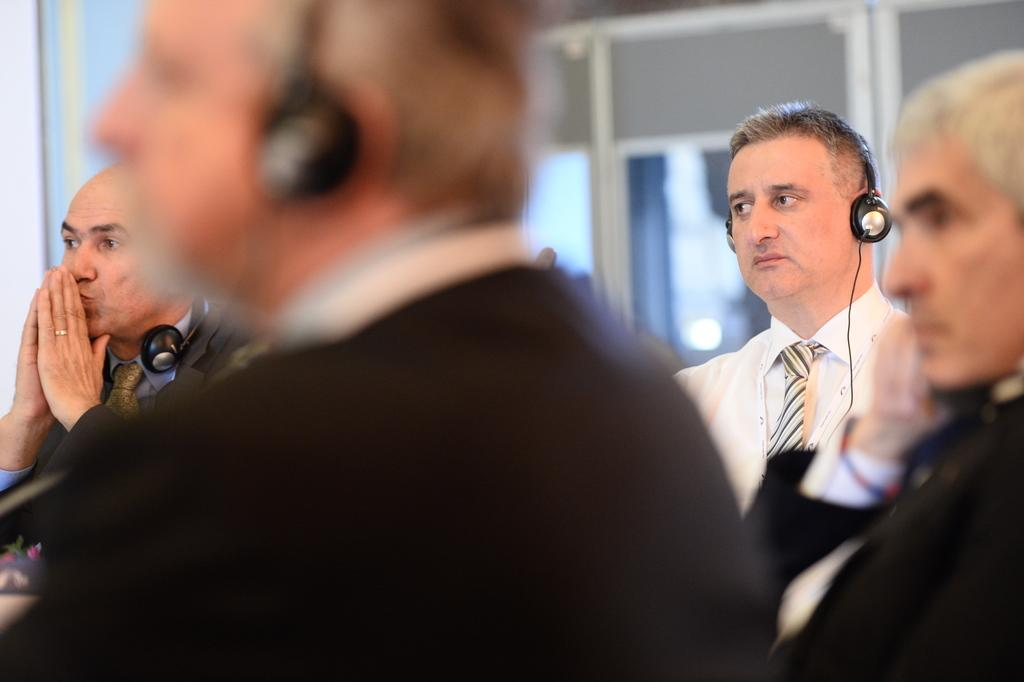Who or what is present in the image? There are people in the image. What are the people wearing? The people are wearing clothes and ties. What can be seen on the people's heads in the image? There are headsets visible in the image. Can you describe the background of the image? The background of the image is blurred. What type of toys can be seen being used for payment in the image? There are no toys or payment transactions present in the image. What color is the chalk used to draw on the people's faces in the image? There is no chalk or drawing on the people's faces in the image. 